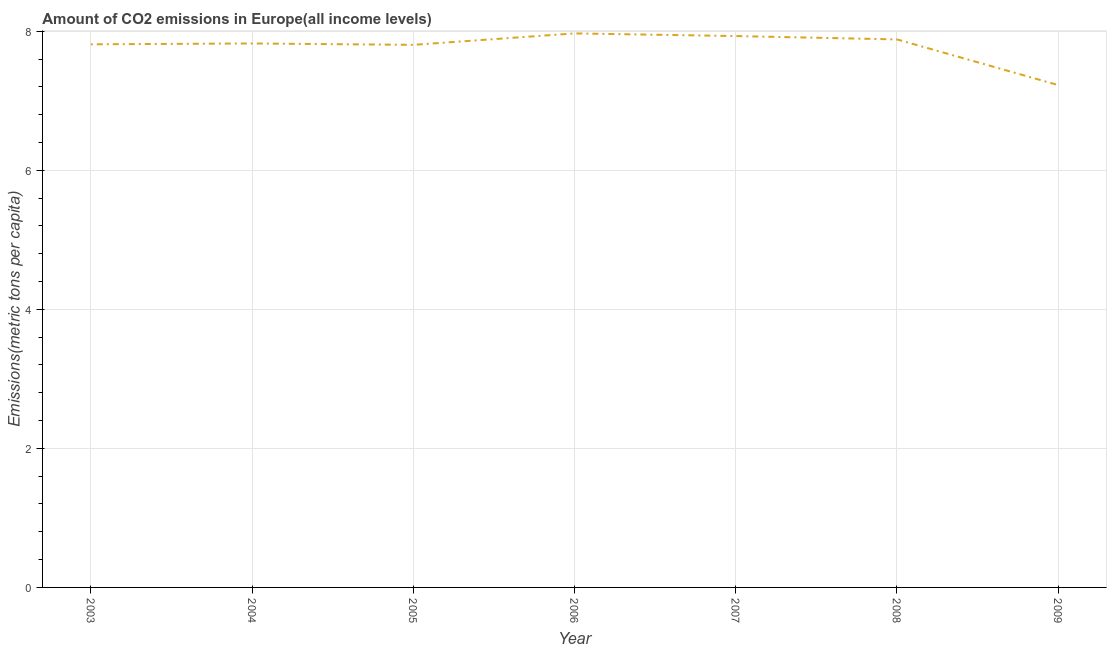What is the amount of co2 emissions in 2004?
Keep it short and to the point. 7.82. Across all years, what is the maximum amount of co2 emissions?
Provide a short and direct response. 7.97. Across all years, what is the minimum amount of co2 emissions?
Provide a succinct answer. 7.23. What is the sum of the amount of co2 emissions?
Your answer should be very brief. 54.45. What is the difference between the amount of co2 emissions in 2003 and 2008?
Offer a very short reply. -0.07. What is the average amount of co2 emissions per year?
Keep it short and to the point. 7.78. What is the median amount of co2 emissions?
Your response must be concise. 7.82. What is the ratio of the amount of co2 emissions in 2006 to that in 2007?
Make the answer very short. 1. Is the amount of co2 emissions in 2003 less than that in 2008?
Offer a very short reply. Yes. What is the difference between the highest and the second highest amount of co2 emissions?
Give a very brief answer. 0.04. What is the difference between the highest and the lowest amount of co2 emissions?
Make the answer very short. 0.74. In how many years, is the amount of co2 emissions greater than the average amount of co2 emissions taken over all years?
Ensure brevity in your answer.  6. What is the difference between two consecutive major ticks on the Y-axis?
Offer a terse response. 2. Does the graph contain any zero values?
Your answer should be compact. No. What is the title of the graph?
Ensure brevity in your answer.  Amount of CO2 emissions in Europe(all income levels). What is the label or title of the Y-axis?
Make the answer very short. Emissions(metric tons per capita). What is the Emissions(metric tons per capita) in 2003?
Provide a short and direct response. 7.81. What is the Emissions(metric tons per capita) of 2004?
Make the answer very short. 7.82. What is the Emissions(metric tons per capita) in 2005?
Make the answer very short. 7.8. What is the Emissions(metric tons per capita) of 2006?
Make the answer very short. 7.97. What is the Emissions(metric tons per capita) in 2007?
Give a very brief answer. 7.93. What is the Emissions(metric tons per capita) in 2008?
Your answer should be very brief. 7.88. What is the Emissions(metric tons per capita) of 2009?
Make the answer very short. 7.23. What is the difference between the Emissions(metric tons per capita) in 2003 and 2004?
Your answer should be very brief. -0.01. What is the difference between the Emissions(metric tons per capita) in 2003 and 2005?
Offer a terse response. 0.01. What is the difference between the Emissions(metric tons per capita) in 2003 and 2006?
Offer a terse response. -0.16. What is the difference between the Emissions(metric tons per capita) in 2003 and 2007?
Give a very brief answer. -0.12. What is the difference between the Emissions(metric tons per capita) in 2003 and 2008?
Keep it short and to the point. -0.07. What is the difference between the Emissions(metric tons per capita) in 2003 and 2009?
Keep it short and to the point. 0.59. What is the difference between the Emissions(metric tons per capita) in 2004 and 2005?
Your answer should be very brief. 0.02. What is the difference between the Emissions(metric tons per capita) in 2004 and 2006?
Provide a short and direct response. -0.14. What is the difference between the Emissions(metric tons per capita) in 2004 and 2007?
Make the answer very short. -0.11. What is the difference between the Emissions(metric tons per capita) in 2004 and 2008?
Ensure brevity in your answer.  -0.06. What is the difference between the Emissions(metric tons per capita) in 2004 and 2009?
Ensure brevity in your answer.  0.6. What is the difference between the Emissions(metric tons per capita) in 2005 and 2006?
Offer a very short reply. -0.16. What is the difference between the Emissions(metric tons per capita) in 2005 and 2007?
Offer a terse response. -0.13. What is the difference between the Emissions(metric tons per capita) in 2005 and 2008?
Make the answer very short. -0.08. What is the difference between the Emissions(metric tons per capita) in 2005 and 2009?
Keep it short and to the point. 0.58. What is the difference between the Emissions(metric tons per capita) in 2006 and 2007?
Give a very brief answer. 0.04. What is the difference between the Emissions(metric tons per capita) in 2006 and 2008?
Keep it short and to the point. 0.09. What is the difference between the Emissions(metric tons per capita) in 2006 and 2009?
Provide a succinct answer. 0.74. What is the difference between the Emissions(metric tons per capita) in 2007 and 2008?
Give a very brief answer. 0.05. What is the difference between the Emissions(metric tons per capita) in 2007 and 2009?
Ensure brevity in your answer.  0.7. What is the difference between the Emissions(metric tons per capita) in 2008 and 2009?
Offer a terse response. 0.66. What is the ratio of the Emissions(metric tons per capita) in 2003 to that in 2004?
Offer a very short reply. 1. What is the ratio of the Emissions(metric tons per capita) in 2003 to that in 2005?
Give a very brief answer. 1. What is the ratio of the Emissions(metric tons per capita) in 2003 to that in 2006?
Give a very brief answer. 0.98. What is the ratio of the Emissions(metric tons per capita) in 2003 to that in 2007?
Offer a terse response. 0.98. What is the ratio of the Emissions(metric tons per capita) in 2003 to that in 2008?
Your response must be concise. 0.99. What is the ratio of the Emissions(metric tons per capita) in 2003 to that in 2009?
Your response must be concise. 1.08. What is the ratio of the Emissions(metric tons per capita) in 2004 to that in 2005?
Your answer should be very brief. 1. What is the ratio of the Emissions(metric tons per capita) in 2004 to that in 2007?
Your answer should be very brief. 0.99. What is the ratio of the Emissions(metric tons per capita) in 2004 to that in 2008?
Your answer should be very brief. 0.99. What is the ratio of the Emissions(metric tons per capita) in 2004 to that in 2009?
Offer a terse response. 1.08. What is the ratio of the Emissions(metric tons per capita) in 2005 to that in 2006?
Ensure brevity in your answer.  0.98. What is the ratio of the Emissions(metric tons per capita) in 2005 to that in 2009?
Your answer should be very brief. 1.08. What is the ratio of the Emissions(metric tons per capita) in 2006 to that in 2007?
Keep it short and to the point. 1. What is the ratio of the Emissions(metric tons per capita) in 2006 to that in 2009?
Ensure brevity in your answer.  1.1. What is the ratio of the Emissions(metric tons per capita) in 2007 to that in 2009?
Offer a terse response. 1.1. What is the ratio of the Emissions(metric tons per capita) in 2008 to that in 2009?
Make the answer very short. 1.09. 